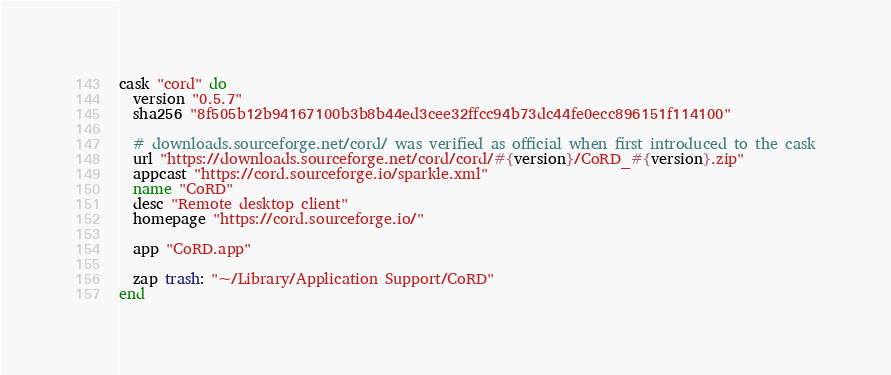<code> <loc_0><loc_0><loc_500><loc_500><_Ruby_>cask "cord" do
  version "0.5.7"
  sha256 "8f505b12b94167100b3b8b44ed3cee32ffcc94b73dc44fe0ecc896151f114100"

  # downloads.sourceforge.net/cord/ was verified as official when first introduced to the cask
  url "https://downloads.sourceforge.net/cord/cord/#{version}/CoRD_#{version}.zip"
  appcast "https://cord.sourceforge.io/sparkle.xml"
  name "CoRD"
  desc "Remote desktop client"
  homepage "https://cord.sourceforge.io/"

  app "CoRD.app"

  zap trash: "~/Library/Application Support/CoRD"
end
</code> 